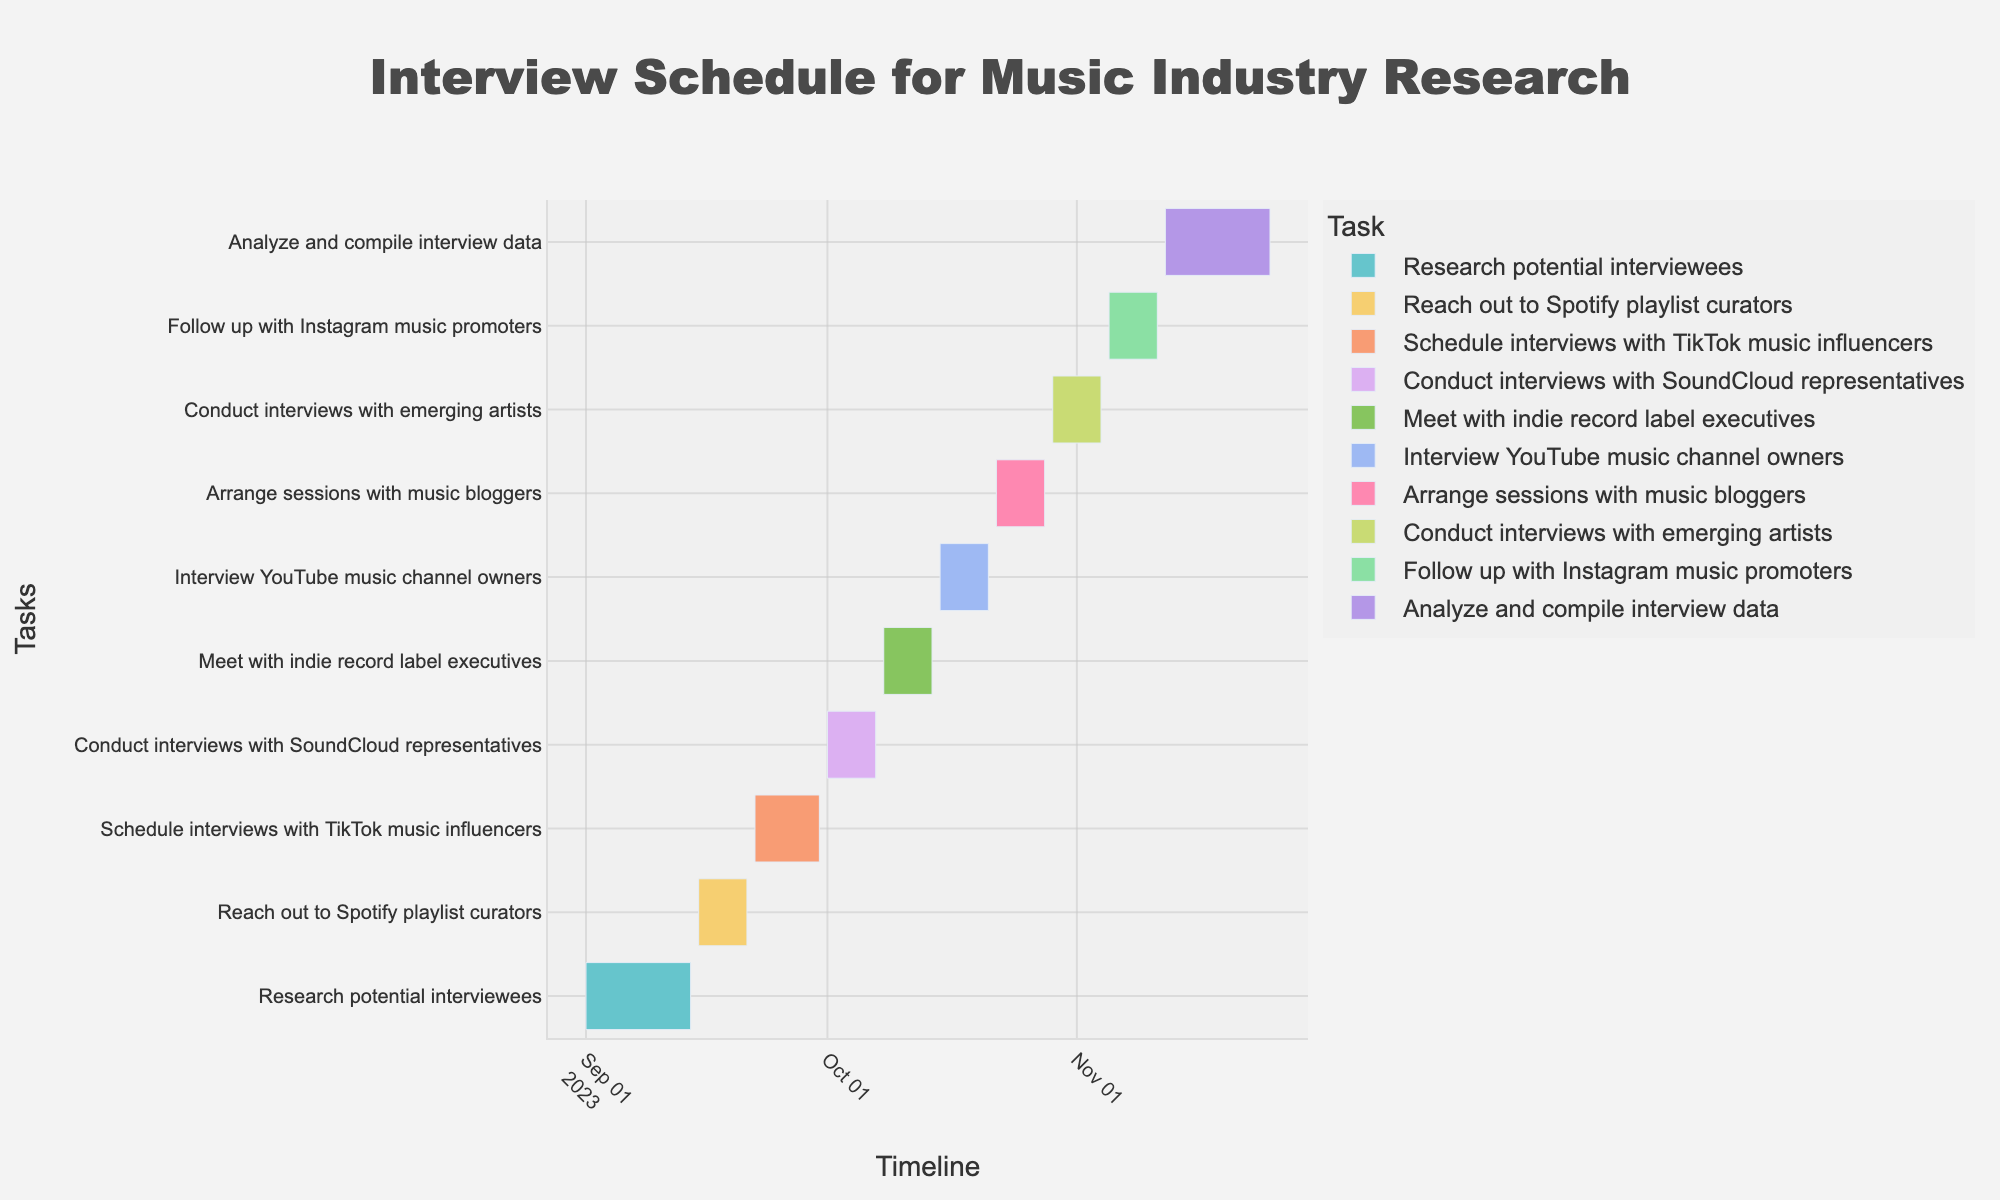What's the title of the Gantt chart? The title of the chart is located at the top center of the figure and is usually displayed prominently in a larger font size. The title is "Interview Schedule for Music Industry Research."
Answer: Interview Schedule for Music Industry Research When does the first task begin and end? Locate the first task in the list vertically on the Y-axis and check the corresponding start and end dates on the X-axis. The first task "Research potential interviewees" starts on September 1, 2023, and ends on September 14, 2023.
Answer: September 1, 2023, to September 14, 2023 How long is the task of "Conduct interviews with SoundCloud representatives"? Identify the task "Conduct interviews with SoundCloud representatives" on the Y-axis and view its corresponding start and end dates on the X-axis. This task starts on October 1, 2023, and ends on October 7, 2023. The duration is calculated based on the start and end dates.
Answer: 7 days Which task ends on November 11, 2023? Review the end dates displayed on the X-axis for each task and find the task that ends on November 11, 2023. The task "Follow up with Instagram music promoters" has this end date.
Answer: Follow up with Instagram music promoters How many weeks are spent analyzing and compiling interview data? Find the task "Analyze and compile interview data" on the Y-axis and check its duration from the start to end date. The task runs from November 12, 2023, to November 25, 2023. Calculate the number of days and divide by 7 to determine the weeks.
Answer: 2 weeks Which task has the shortest duration? Compare the durations of all tasks by referring to the length of each task bar on the Gantt chart. The task with the shortest bar is "Reach out to Spotify playlist curators."
Answer: Reach out to Spotify playlist curators Do any tasks overlap in the same period? Visually inspect the Gantt chart for tasks that have overlapping periods (bars that intersect in time). The tasks "Schedule interviews with TikTok music influencers" and "Conduct interviews with SoundCloud representatives" overlap from September 30, 2023, to October 1, 2023.
Answer: Yes What is the total duration for all tasks combined? Calculate the duration of each task individually by subtracting the start date from the end date, then sum the total number of days for all the tasks. Sum: 14 (Research potential interviewees) + 7 (Reach out to Spotify playlist curators) + 9 (Schedule interviews with TikTok music influencers) + 7 (Conduct interviews with SoundCloud representatives) + 7 (Meet with indie record label executives) + 7 (Interview YouTube music channel owners) + 7 (Arrange sessions with music bloggers) + 7 (Conduct interviews with emerging artists) + 7 (Follow up with Instagram music promoters) + 14 (Analyze and compile interview data) = 86 days
Answer: 86 days Which tasks are conducted in October 2023? Look at the timeline on the X-axis in October 2023 and see which task bars fall within this range. The tasks are "Conduct interviews with SoundCloud representatives," "Meet with indie record label executives," "Interview YouTube music channel owners," "Arrange sessions with music bloggers," and "Conduct interviews with emerging artists."
Answer: 5 tasks How many tasks are there in total? Count the number of tasks listed along the Y-axis. There are a total of 10 tasks.
Answer: 10 tasks 